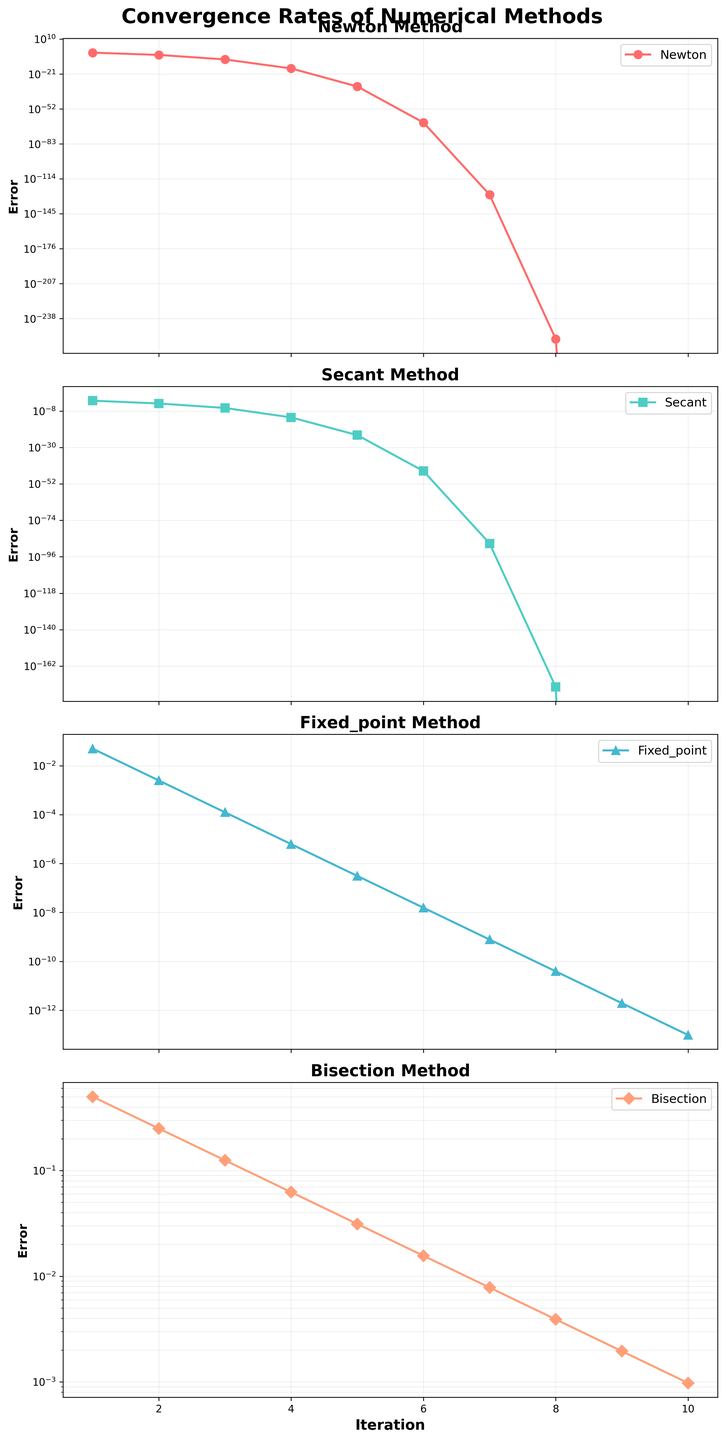What's the error value for the Newton method at the 5th iteration? To find the error value for the Newton method at the 5th iteration, look at the subplot for the Newton method and identify the data point corresponding to iteration 5.
Answer: 1.0e-32 At which iteration does the Secant method first achieve an error value less than 1.0e-10? To find the first iteration where the Secant method error value is less than 1.0e-10, observe the subplot for the Secant method and identify the iteration number where the error value drops below the threshold.
Answer: Iteration 4 Which numerical method converges to an error of 1.0e-12 faster, Newton or Fixed-Point? Compare the plots of the Newton and Fixed-Point methods to see at which iteration each method reaches or surpasses an error value of 1.0e-12 for the first time.
Answer: Newton At iteration 3, which method has the highest error value? To determine which method has the highest error value at iteration 3, compare the error values for all four methods at iteration 3 in their respective subplots.
Answer: Fixed-Point Compare the convergence rates of the Newton method and Bisection method. At which iteration does the Bisection method first have an error value less than the Newton method's initial error? Observe the Newton method's initial error value at iteration 1, which is 1.0e-2. Look at the Bisection method's subplot to determine when its error value first drops below 1.0e-2.
Answer: Iteration 2 What's the ratio of the error value of the Secant method to the Fixed-Point method at iteration 6? Obtain the error values of the Secant and Fixed-Point methods at iteration 6 from their respective subplots, then calculate the ratio by dividing the Secant method's error by the Fixed-Point method's error (6.4e-45 / 1.5625e-8).
Answer: 4.096e-37 How many iterations does it take for the Bisection method to reach an error of less than 1.0e-3? Identify when the Bisection method's error value first drops below 1.0e-3 by observing its subplot and counting the iterations taken to reach this threshold.
Answer: 10 iterations Rank the numerical methods by their final error values at iteration 10 from smallest to largest. Look at the error values for each numerical method at iteration 10 in their respective subplots, then rank them from the smallest to the largest error value.
Answer: Newton, Secant, Fixed-Point, Bisection What is the approximate difference in error values between the Newton and Fixed-Point methods at iteration 7? Find the error values for the Newton and Fixed-Point methods at iteration 7 from their subplots and calculate the difference (1.0e-128 - 7.8125e-10).
Answer: Approximately 1.0e-128 Which method shows the most consistent rate of convergence over the iterations? To determine the most consistent convergence rate, observe the shapes of the curves for each method. A consistent rate will show a smooth and steady decline in error values across iterations.
Answer: Fixed-Point 